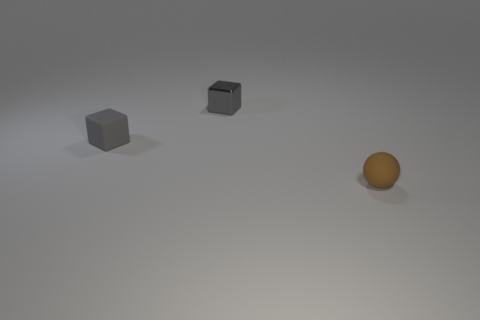Add 1 brown matte things. How many objects exist? 4 Subtract all balls. How many objects are left? 2 Add 2 big green objects. How many big green objects exist? 2 Subtract 0 blue cylinders. How many objects are left? 3 Subtract all tiny gray blocks. Subtract all blue things. How many objects are left? 1 Add 1 gray matte things. How many gray matte things are left? 2 